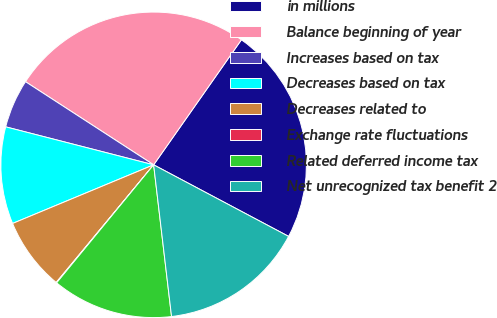Convert chart. <chart><loc_0><loc_0><loc_500><loc_500><pie_chart><fcel>in millions<fcel>Balance beginning of year<fcel>Increases based on tax<fcel>Decreases based on tax<fcel>Decreases related to<fcel>Exchange rate fluctuations<fcel>Related deferred income tax<fcel>Net unrecognized tax benefit 2<nl><fcel>23.02%<fcel>25.58%<fcel>5.16%<fcel>10.27%<fcel>7.72%<fcel>0.06%<fcel>12.82%<fcel>15.37%<nl></chart> 